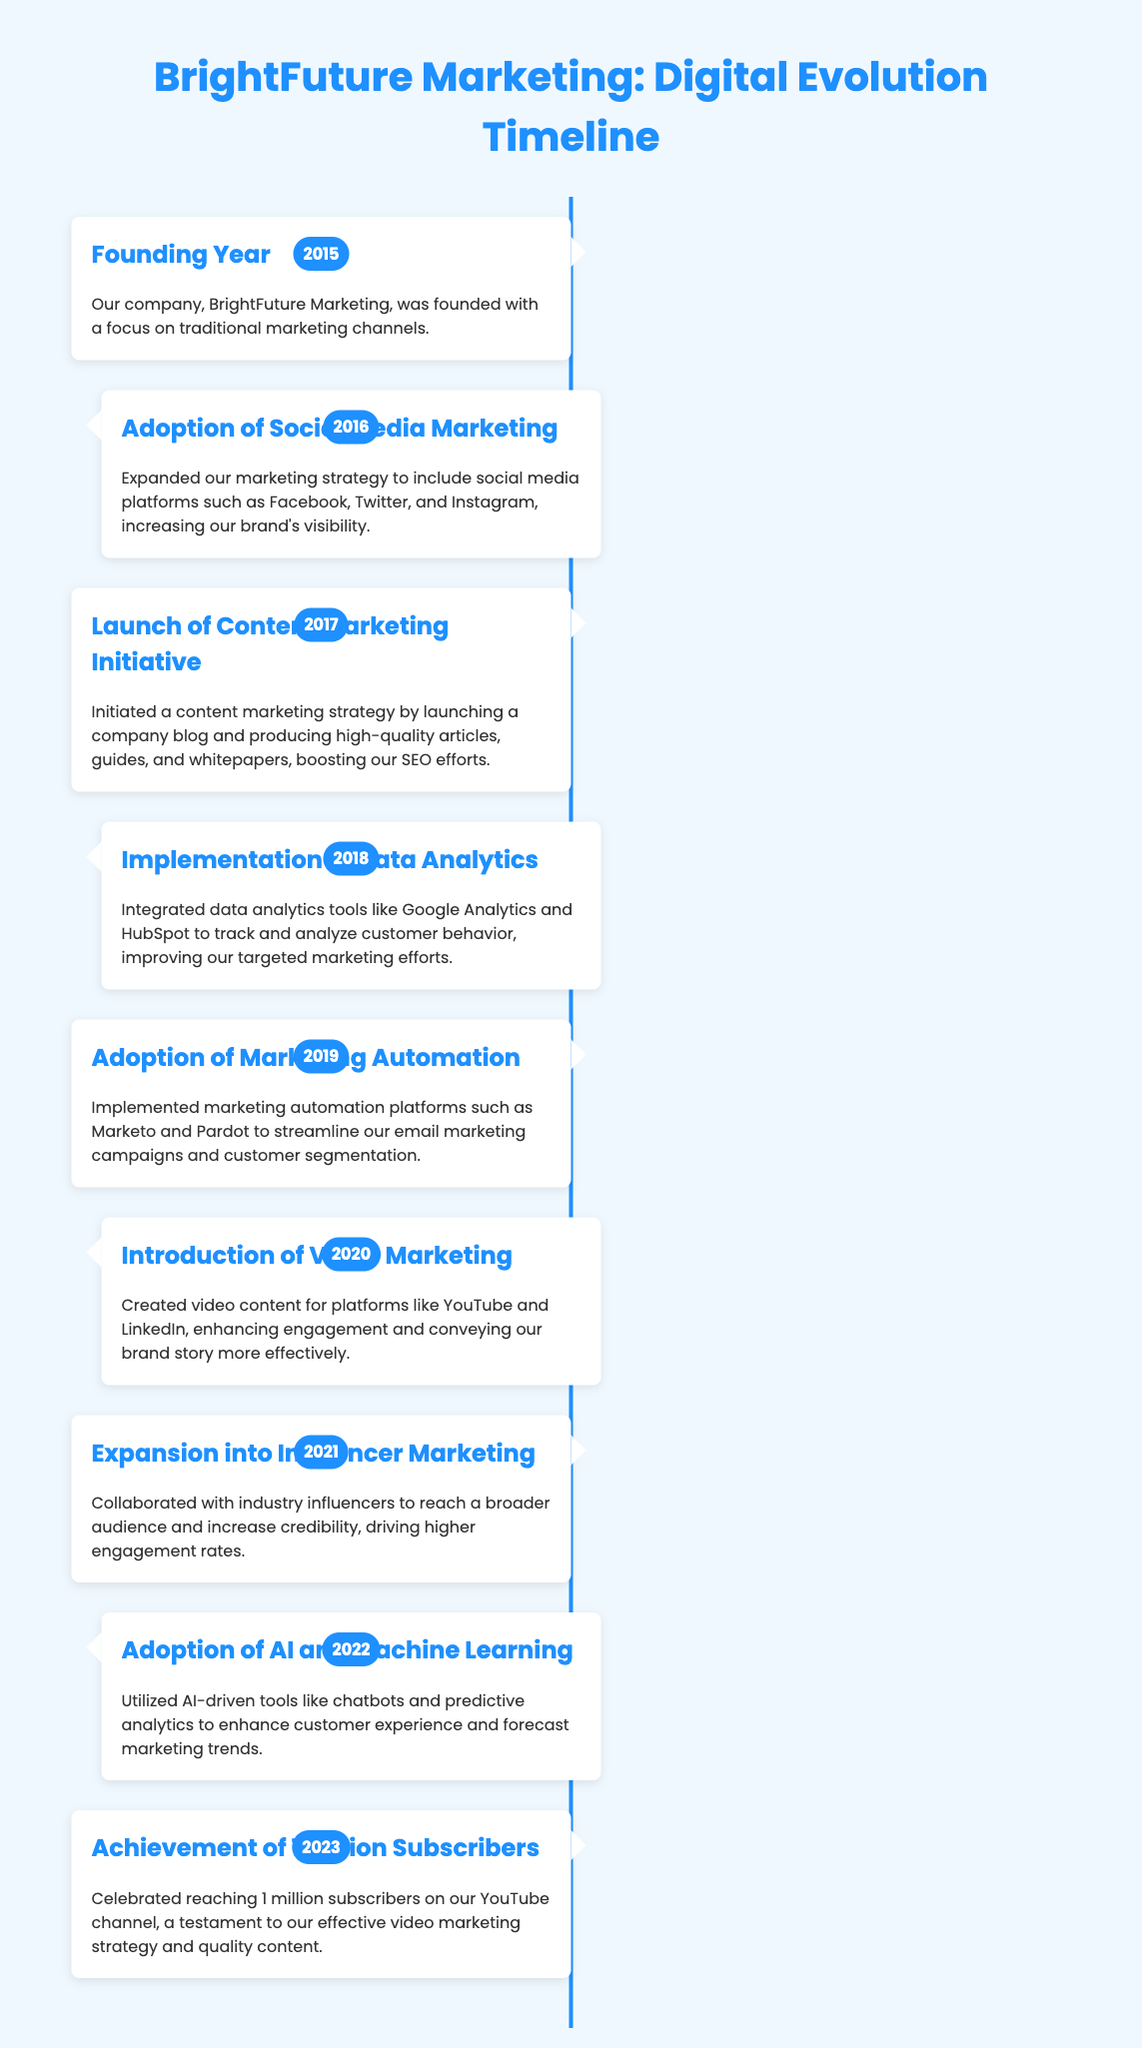what year was BrightFuture Marketing founded? The document states that BrightFuture Marketing was founded in the year 2015.
Answer: 2015 what was the focus of the company at its founding? The text mentions that the focus was on traditional marketing channels.
Answer: traditional marketing channels which social media platforms were adopted in 2016? The document lists Facebook, Twitter, and Instagram as the platforms adopted in 2016.
Answer: Facebook, Twitter, and Instagram what marketing strategy was launched in 2017? The timeline indicates that a content marketing strategy was initiated in 2017.
Answer: content marketing strategy which tools were integrated in 2018? The document specifies that Google Analytics and HubSpot were integrated to track and analyze customer behavior.
Answer: Google Analytics and HubSpot what notable marketing method was introduced in 2020? The document mentions the introduction of video marketing as a key method in 2020.
Answer: video marketing how many subscribers did the company achieve in 2023? According to the timeline, BrightFuture Marketing achieved 1 million subscribers on their YouTube channel in 2023.
Answer: 1 million subscribers what year did BrightFuture Marketing adopt AI and machine learning? The timeline states that this adoption occurred in the year 2022.
Answer: 2022 which marketing strategy expanded in 2021? The document highlights the expansion into influencer marketing in 2021.
Answer: influencer marketing 